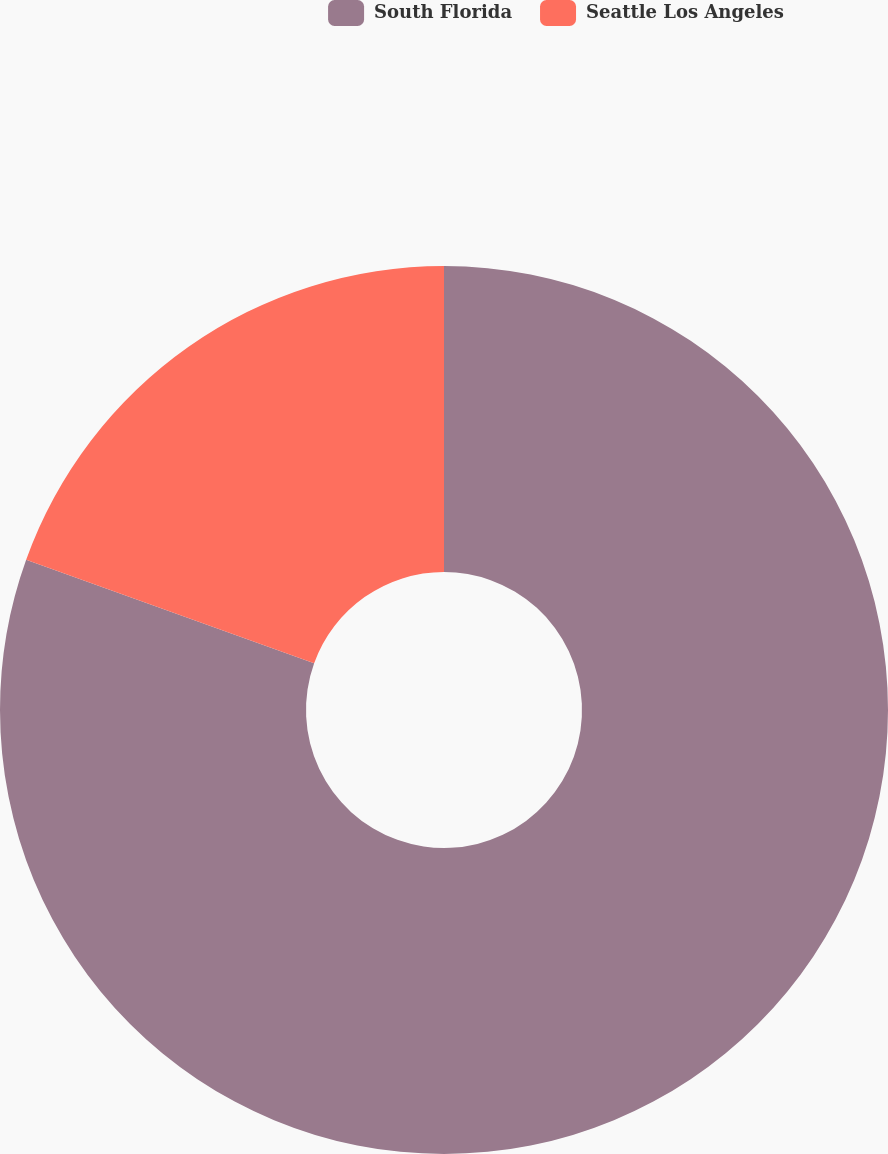Convert chart. <chart><loc_0><loc_0><loc_500><loc_500><pie_chart><fcel>South Florida<fcel>Seattle Los Angeles<nl><fcel>80.49%<fcel>19.51%<nl></chart> 